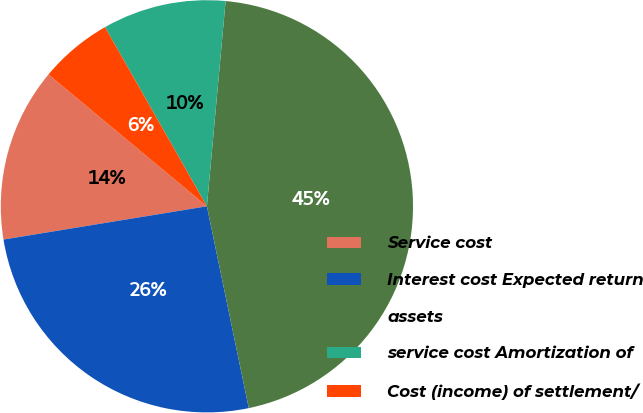Convert chart. <chart><loc_0><loc_0><loc_500><loc_500><pie_chart><fcel>Service cost<fcel>Interest cost Expected return<fcel>assets<fcel>service cost Amortization of<fcel>Cost (income) of settlement/<nl><fcel>13.63%<fcel>25.68%<fcel>45.3%<fcel>9.68%<fcel>5.72%<nl></chart> 